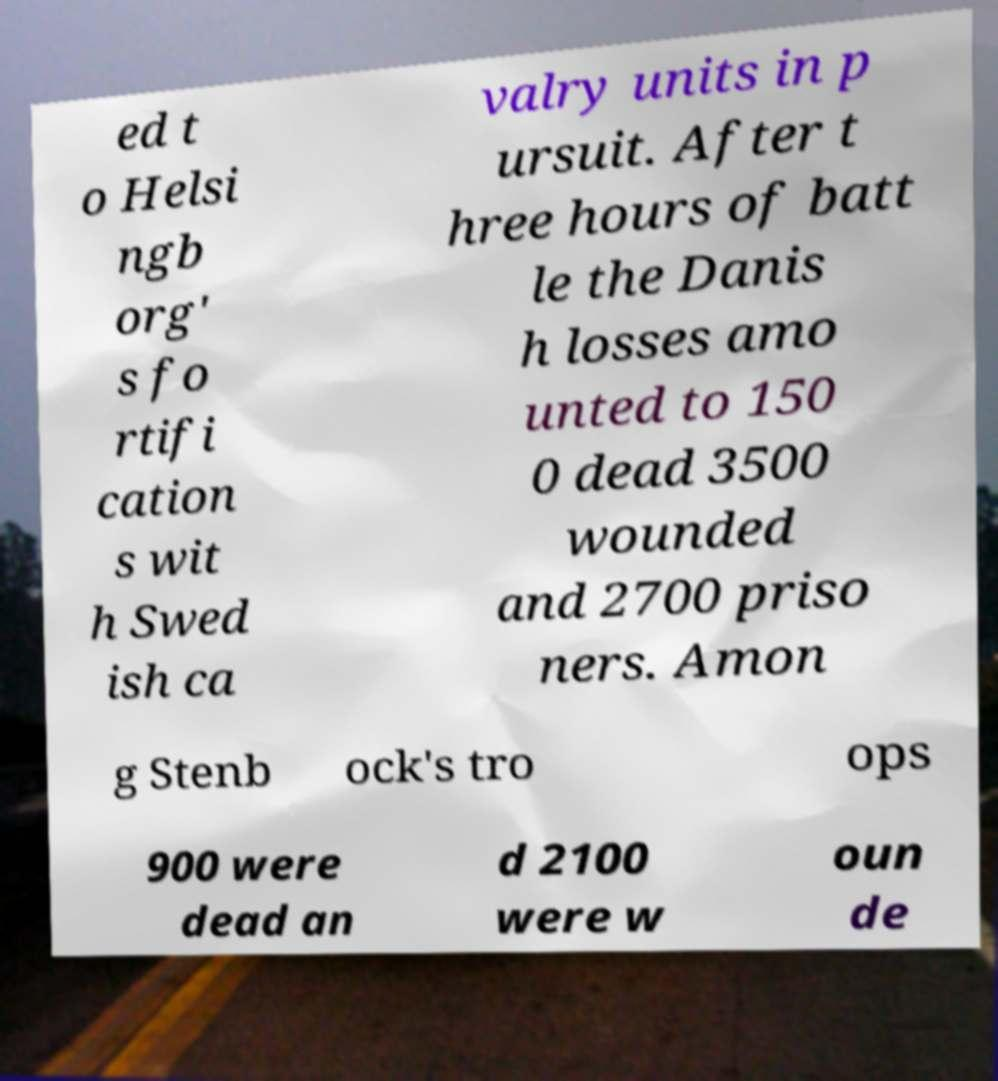Could you extract and type out the text from this image? ed t o Helsi ngb org' s fo rtifi cation s wit h Swed ish ca valry units in p ursuit. After t hree hours of batt le the Danis h losses amo unted to 150 0 dead 3500 wounded and 2700 priso ners. Amon g Stenb ock's tro ops 900 were dead an d 2100 were w oun de 